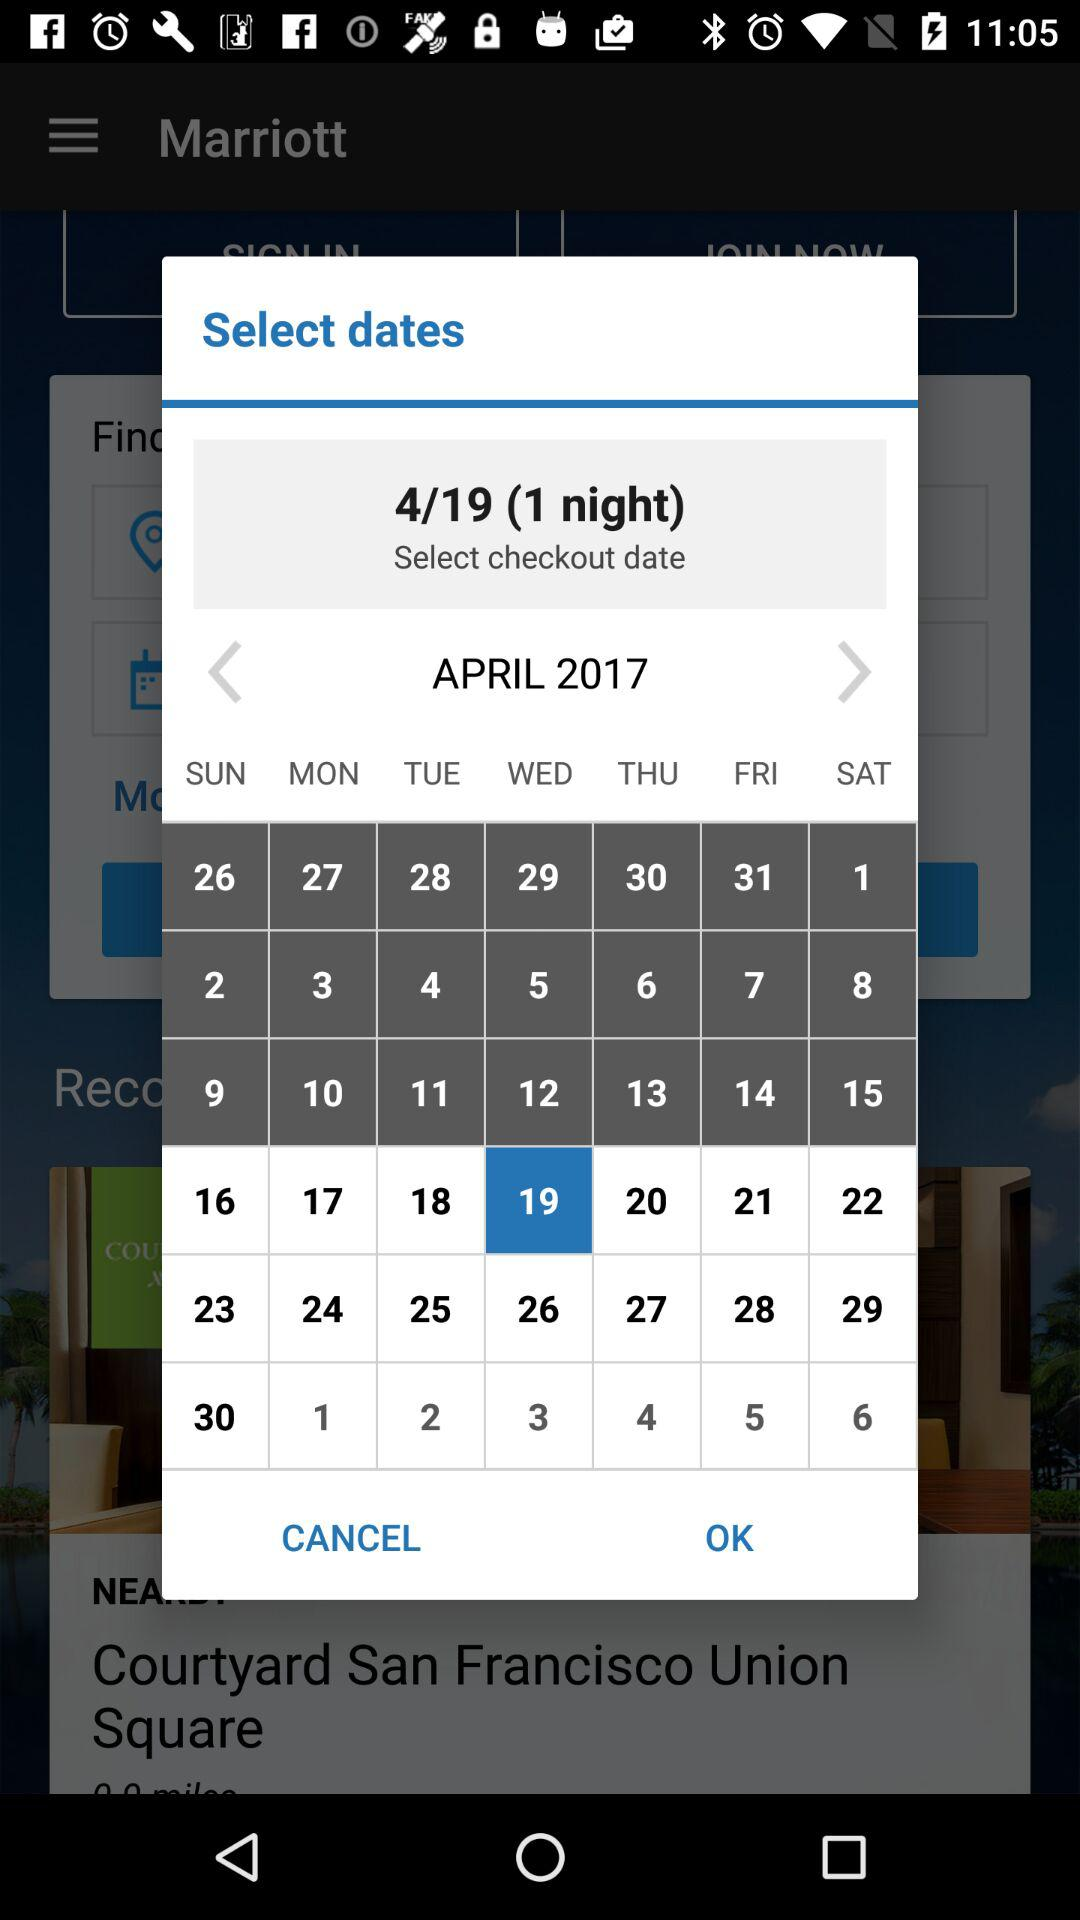What is the date of checkout? The date is Wednesday, April 19, 2017. 